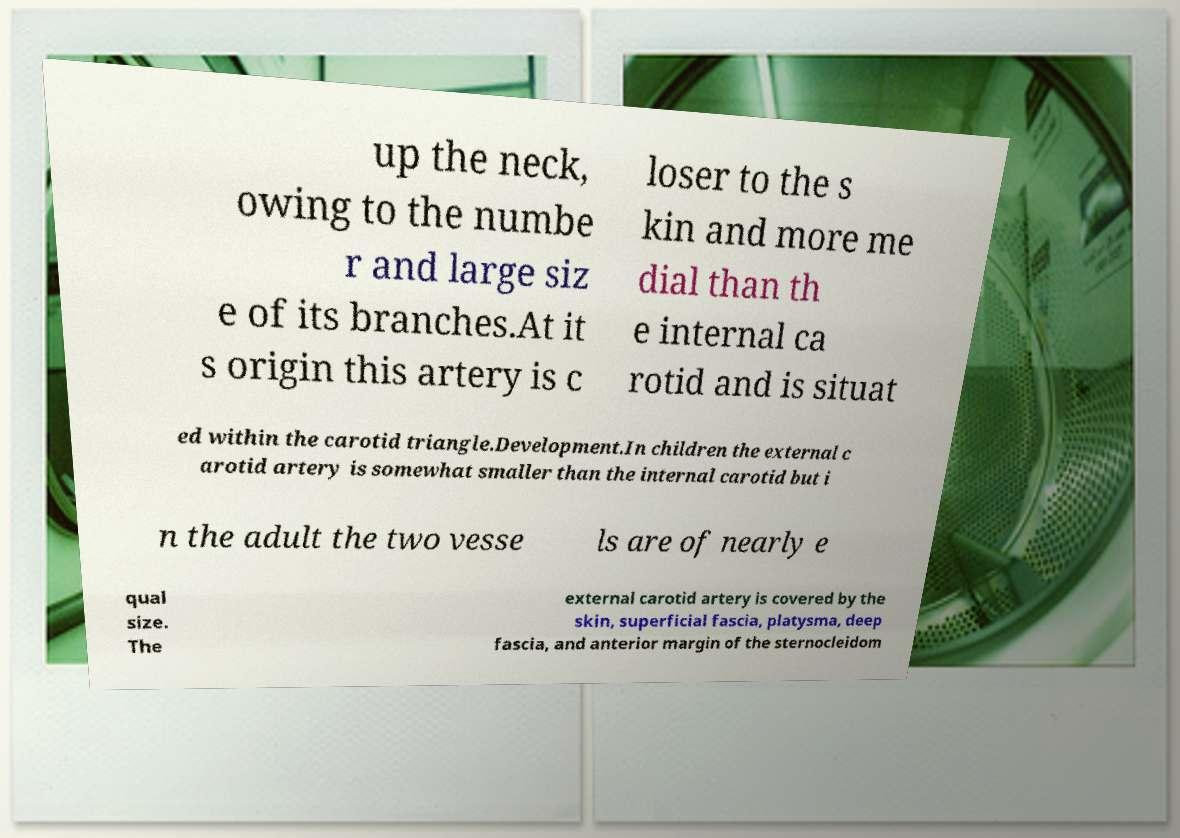Could you assist in decoding the text presented in this image and type it out clearly? up the neck, owing to the numbe r and large siz e of its branches.At it s origin this artery is c loser to the s kin and more me dial than th e internal ca rotid and is situat ed within the carotid triangle.Development.In children the external c arotid artery is somewhat smaller than the internal carotid but i n the adult the two vesse ls are of nearly e qual size. The external carotid artery is covered by the skin, superficial fascia, platysma, deep fascia, and anterior margin of the sternocleidom 